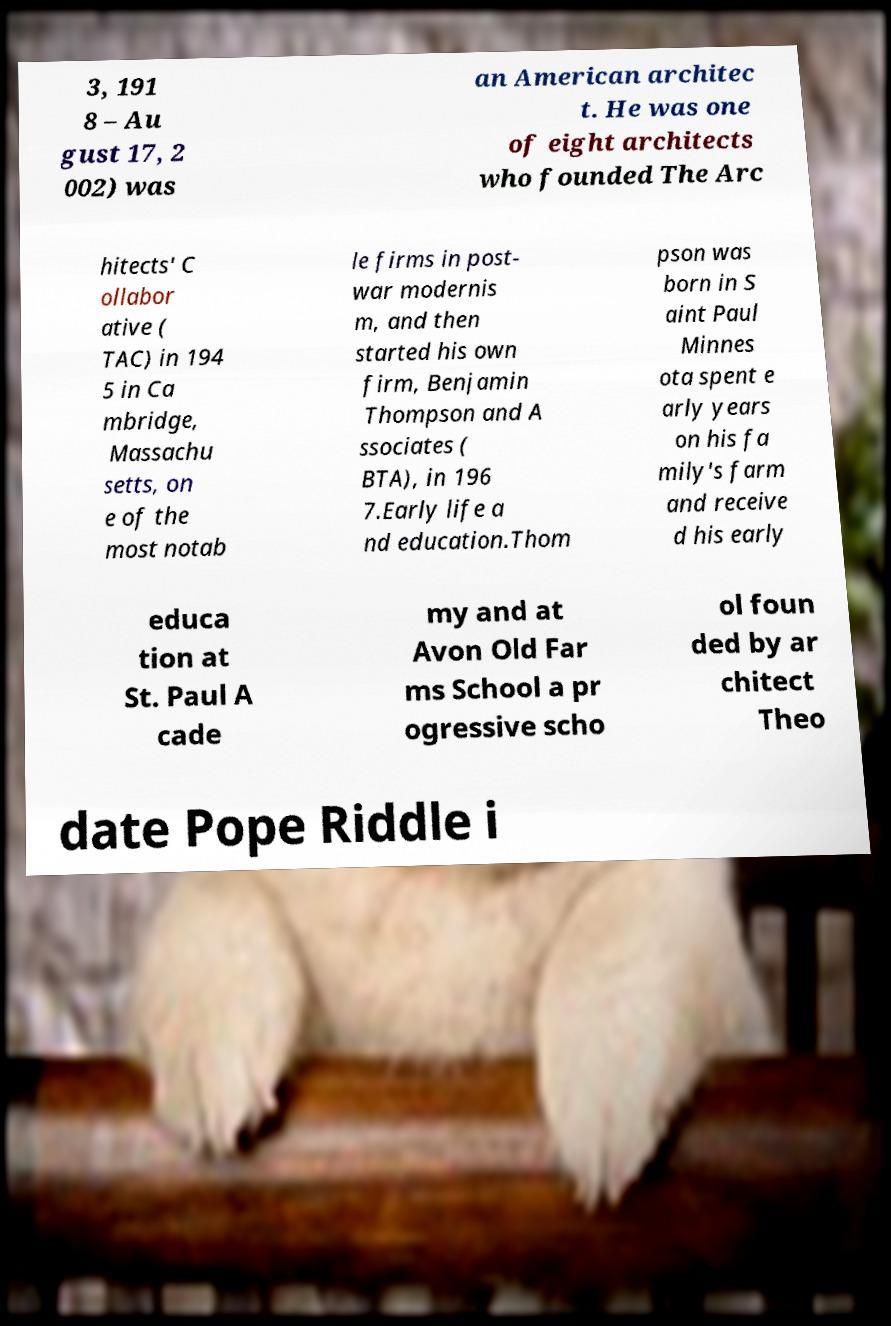Could you assist in decoding the text presented in this image and type it out clearly? 3, 191 8 – Au gust 17, 2 002) was an American architec t. He was one of eight architects who founded The Arc hitects' C ollabor ative ( TAC) in 194 5 in Ca mbridge, Massachu setts, on e of the most notab le firms in post- war modernis m, and then started his own firm, Benjamin Thompson and A ssociates ( BTA), in 196 7.Early life a nd education.Thom pson was born in S aint Paul Minnes ota spent e arly years on his fa mily's farm and receive d his early educa tion at St. Paul A cade my and at Avon Old Far ms School a pr ogressive scho ol foun ded by ar chitect Theo date Pope Riddle i 